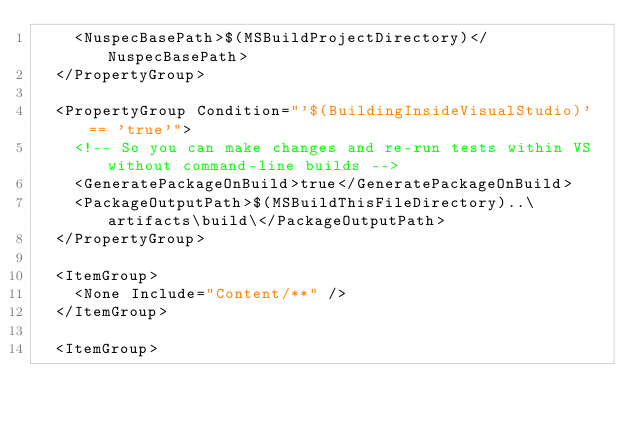<code> <loc_0><loc_0><loc_500><loc_500><_XML_>    <NuspecBasePath>$(MSBuildProjectDirectory)</NuspecBasePath>
  </PropertyGroup>

  <PropertyGroup Condition="'$(BuildingInsideVisualStudio)' == 'true'">
    <!-- So you can make changes and re-run tests within VS without command-line builds -->
    <GeneratePackageOnBuild>true</GeneratePackageOnBuild>
    <PackageOutputPath>$(MSBuildThisFileDirectory)..\artifacts\build\</PackageOutputPath>
  </PropertyGroup>

  <ItemGroup>
    <None Include="Content/**" />
  </ItemGroup>

  <ItemGroup></code> 